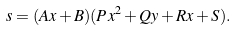<formula> <loc_0><loc_0><loc_500><loc_500>s = ( A x + B ) ( P x ^ { 2 } + Q y + R x + S ) .</formula> 